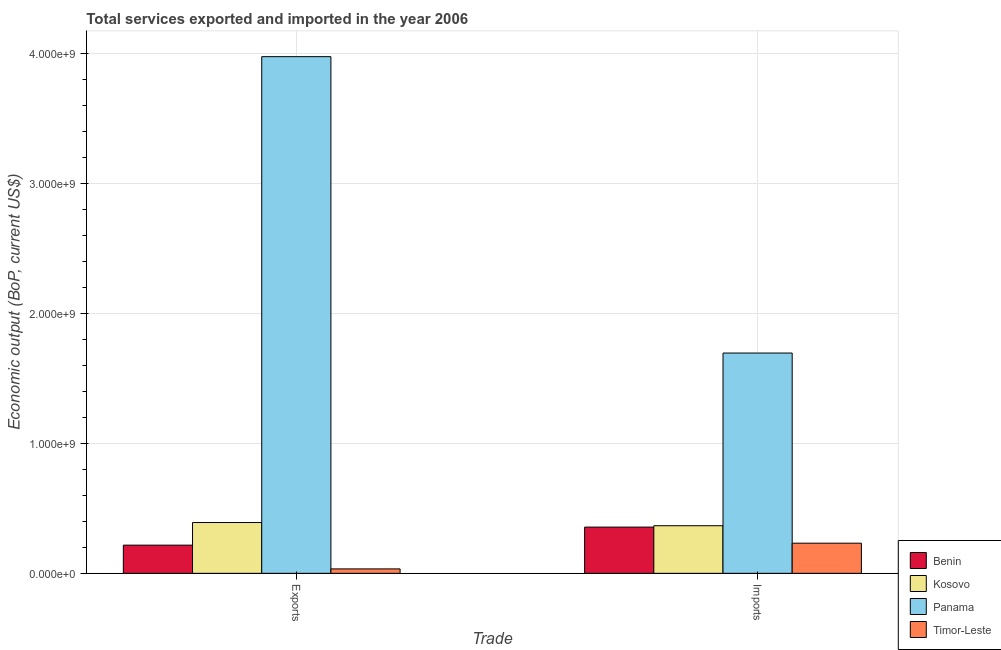How many groups of bars are there?
Offer a very short reply. 2. What is the label of the 1st group of bars from the left?
Make the answer very short. Exports. What is the amount of service exports in Benin?
Offer a terse response. 2.17e+08. Across all countries, what is the maximum amount of service imports?
Ensure brevity in your answer.  1.70e+09. Across all countries, what is the minimum amount of service exports?
Keep it short and to the point. 3.41e+07. In which country was the amount of service imports maximum?
Make the answer very short. Panama. In which country was the amount of service imports minimum?
Offer a very short reply. Timor-Leste. What is the total amount of service imports in the graph?
Ensure brevity in your answer.  2.65e+09. What is the difference between the amount of service exports in Panama and that in Benin?
Make the answer very short. 3.76e+09. What is the difference between the amount of service exports in Kosovo and the amount of service imports in Panama?
Provide a short and direct response. -1.31e+09. What is the average amount of service imports per country?
Make the answer very short. 6.63e+08. What is the difference between the amount of service exports and amount of service imports in Kosovo?
Your answer should be compact. 2.46e+07. In how many countries, is the amount of service exports greater than 600000000 US$?
Your answer should be very brief. 1. What is the ratio of the amount of service exports in Benin to that in Kosovo?
Make the answer very short. 0.55. Is the amount of service exports in Panama less than that in Kosovo?
Your answer should be very brief. No. What does the 2nd bar from the left in Imports represents?
Give a very brief answer. Kosovo. What does the 4th bar from the right in Exports represents?
Provide a succinct answer. Benin. How many bars are there?
Ensure brevity in your answer.  8. Are the values on the major ticks of Y-axis written in scientific E-notation?
Give a very brief answer. Yes. Does the graph contain grids?
Ensure brevity in your answer.  Yes. How many legend labels are there?
Make the answer very short. 4. What is the title of the graph?
Ensure brevity in your answer.  Total services exported and imported in the year 2006. What is the label or title of the X-axis?
Give a very brief answer. Trade. What is the label or title of the Y-axis?
Ensure brevity in your answer.  Economic output (BoP, current US$). What is the Economic output (BoP, current US$) in Benin in Exports?
Make the answer very short. 2.17e+08. What is the Economic output (BoP, current US$) of Kosovo in Exports?
Make the answer very short. 3.91e+08. What is the Economic output (BoP, current US$) of Panama in Exports?
Provide a succinct answer. 3.98e+09. What is the Economic output (BoP, current US$) of Timor-Leste in Exports?
Your response must be concise. 3.41e+07. What is the Economic output (BoP, current US$) of Benin in Imports?
Offer a terse response. 3.56e+08. What is the Economic output (BoP, current US$) in Kosovo in Imports?
Offer a very short reply. 3.67e+08. What is the Economic output (BoP, current US$) in Panama in Imports?
Your response must be concise. 1.70e+09. What is the Economic output (BoP, current US$) of Timor-Leste in Imports?
Your response must be concise. 2.32e+08. Across all Trade, what is the maximum Economic output (BoP, current US$) in Benin?
Provide a short and direct response. 3.56e+08. Across all Trade, what is the maximum Economic output (BoP, current US$) of Kosovo?
Offer a terse response. 3.91e+08. Across all Trade, what is the maximum Economic output (BoP, current US$) of Panama?
Offer a terse response. 3.98e+09. Across all Trade, what is the maximum Economic output (BoP, current US$) of Timor-Leste?
Provide a short and direct response. 2.32e+08. Across all Trade, what is the minimum Economic output (BoP, current US$) in Benin?
Make the answer very short. 2.17e+08. Across all Trade, what is the minimum Economic output (BoP, current US$) in Kosovo?
Ensure brevity in your answer.  3.67e+08. Across all Trade, what is the minimum Economic output (BoP, current US$) of Panama?
Provide a short and direct response. 1.70e+09. Across all Trade, what is the minimum Economic output (BoP, current US$) in Timor-Leste?
Offer a very short reply. 3.41e+07. What is the total Economic output (BoP, current US$) of Benin in the graph?
Your answer should be very brief. 5.73e+08. What is the total Economic output (BoP, current US$) of Kosovo in the graph?
Give a very brief answer. 7.58e+08. What is the total Economic output (BoP, current US$) of Panama in the graph?
Your answer should be very brief. 5.67e+09. What is the total Economic output (BoP, current US$) in Timor-Leste in the graph?
Your answer should be very brief. 2.66e+08. What is the difference between the Economic output (BoP, current US$) of Benin in Exports and that in Imports?
Offer a terse response. -1.39e+08. What is the difference between the Economic output (BoP, current US$) in Kosovo in Exports and that in Imports?
Make the answer very short. 2.46e+07. What is the difference between the Economic output (BoP, current US$) in Panama in Exports and that in Imports?
Offer a very short reply. 2.28e+09. What is the difference between the Economic output (BoP, current US$) in Timor-Leste in Exports and that in Imports?
Keep it short and to the point. -1.98e+08. What is the difference between the Economic output (BoP, current US$) of Benin in Exports and the Economic output (BoP, current US$) of Kosovo in Imports?
Your answer should be compact. -1.50e+08. What is the difference between the Economic output (BoP, current US$) of Benin in Exports and the Economic output (BoP, current US$) of Panama in Imports?
Give a very brief answer. -1.48e+09. What is the difference between the Economic output (BoP, current US$) of Benin in Exports and the Economic output (BoP, current US$) of Timor-Leste in Imports?
Provide a succinct answer. -1.51e+07. What is the difference between the Economic output (BoP, current US$) of Kosovo in Exports and the Economic output (BoP, current US$) of Panama in Imports?
Provide a succinct answer. -1.31e+09. What is the difference between the Economic output (BoP, current US$) of Kosovo in Exports and the Economic output (BoP, current US$) of Timor-Leste in Imports?
Your response must be concise. 1.59e+08. What is the difference between the Economic output (BoP, current US$) of Panama in Exports and the Economic output (BoP, current US$) of Timor-Leste in Imports?
Provide a succinct answer. 3.75e+09. What is the average Economic output (BoP, current US$) in Benin per Trade?
Your answer should be compact. 2.87e+08. What is the average Economic output (BoP, current US$) in Kosovo per Trade?
Ensure brevity in your answer.  3.79e+08. What is the average Economic output (BoP, current US$) in Panama per Trade?
Keep it short and to the point. 2.84e+09. What is the average Economic output (BoP, current US$) in Timor-Leste per Trade?
Provide a succinct answer. 1.33e+08. What is the difference between the Economic output (BoP, current US$) in Benin and Economic output (BoP, current US$) in Kosovo in Exports?
Give a very brief answer. -1.74e+08. What is the difference between the Economic output (BoP, current US$) of Benin and Economic output (BoP, current US$) of Panama in Exports?
Your answer should be compact. -3.76e+09. What is the difference between the Economic output (BoP, current US$) of Benin and Economic output (BoP, current US$) of Timor-Leste in Exports?
Your response must be concise. 1.83e+08. What is the difference between the Economic output (BoP, current US$) in Kosovo and Economic output (BoP, current US$) in Panama in Exports?
Your response must be concise. -3.59e+09. What is the difference between the Economic output (BoP, current US$) of Kosovo and Economic output (BoP, current US$) of Timor-Leste in Exports?
Your answer should be compact. 3.57e+08. What is the difference between the Economic output (BoP, current US$) in Panama and Economic output (BoP, current US$) in Timor-Leste in Exports?
Offer a terse response. 3.94e+09. What is the difference between the Economic output (BoP, current US$) of Benin and Economic output (BoP, current US$) of Kosovo in Imports?
Keep it short and to the point. -1.06e+07. What is the difference between the Economic output (BoP, current US$) of Benin and Economic output (BoP, current US$) of Panama in Imports?
Your response must be concise. -1.34e+09. What is the difference between the Economic output (BoP, current US$) of Benin and Economic output (BoP, current US$) of Timor-Leste in Imports?
Make the answer very short. 1.24e+08. What is the difference between the Economic output (BoP, current US$) in Kosovo and Economic output (BoP, current US$) in Panama in Imports?
Offer a very short reply. -1.33e+09. What is the difference between the Economic output (BoP, current US$) of Kosovo and Economic output (BoP, current US$) of Timor-Leste in Imports?
Your answer should be compact. 1.34e+08. What is the difference between the Economic output (BoP, current US$) of Panama and Economic output (BoP, current US$) of Timor-Leste in Imports?
Keep it short and to the point. 1.46e+09. What is the ratio of the Economic output (BoP, current US$) of Benin in Exports to that in Imports?
Your response must be concise. 0.61. What is the ratio of the Economic output (BoP, current US$) of Kosovo in Exports to that in Imports?
Offer a terse response. 1.07. What is the ratio of the Economic output (BoP, current US$) of Panama in Exports to that in Imports?
Keep it short and to the point. 2.35. What is the ratio of the Economic output (BoP, current US$) of Timor-Leste in Exports to that in Imports?
Your answer should be compact. 0.15. What is the difference between the highest and the second highest Economic output (BoP, current US$) in Benin?
Offer a terse response. 1.39e+08. What is the difference between the highest and the second highest Economic output (BoP, current US$) of Kosovo?
Keep it short and to the point. 2.46e+07. What is the difference between the highest and the second highest Economic output (BoP, current US$) in Panama?
Make the answer very short. 2.28e+09. What is the difference between the highest and the second highest Economic output (BoP, current US$) of Timor-Leste?
Provide a succinct answer. 1.98e+08. What is the difference between the highest and the lowest Economic output (BoP, current US$) in Benin?
Your answer should be compact. 1.39e+08. What is the difference between the highest and the lowest Economic output (BoP, current US$) of Kosovo?
Provide a short and direct response. 2.46e+07. What is the difference between the highest and the lowest Economic output (BoP, current US$) in Panama?
Provide a succinct answer. 2.28e+09. What is the difference between the highest and the lowest Economic output (BoP, current US$) of Timor-Leste?
Offer a terse response. 1.98e+08. 